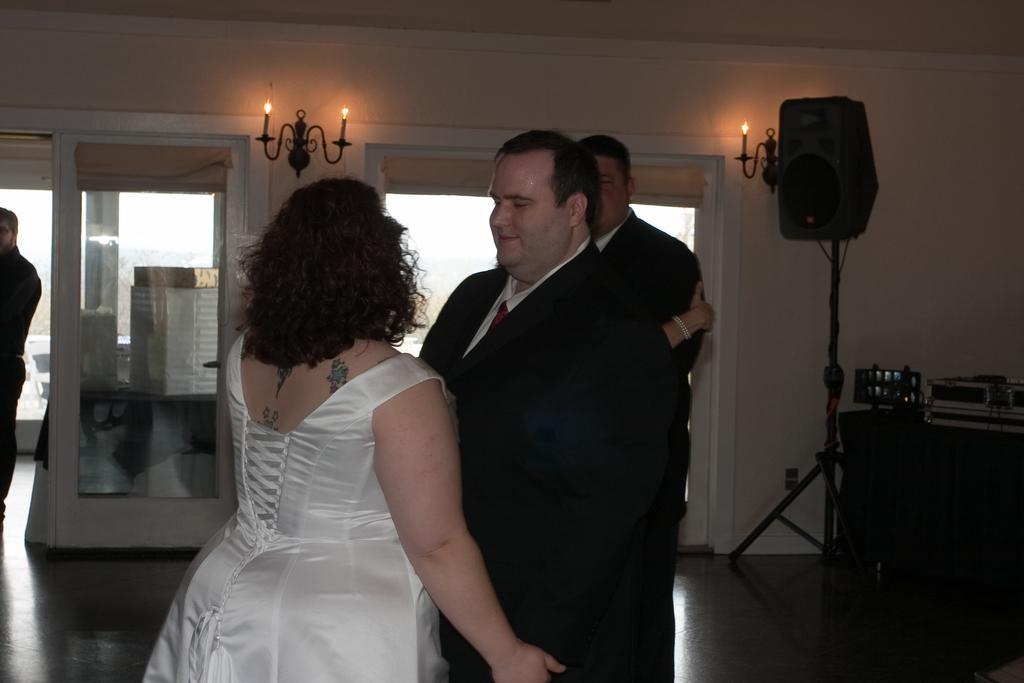Can you describe this image briefly? In this image there is a couple who are standing on the floor. In the background there is a glass door. On the right side there is a speaker kept on the stand. Beside it there is a table on which there is a box. At the top there is a candle stand with the candles. 